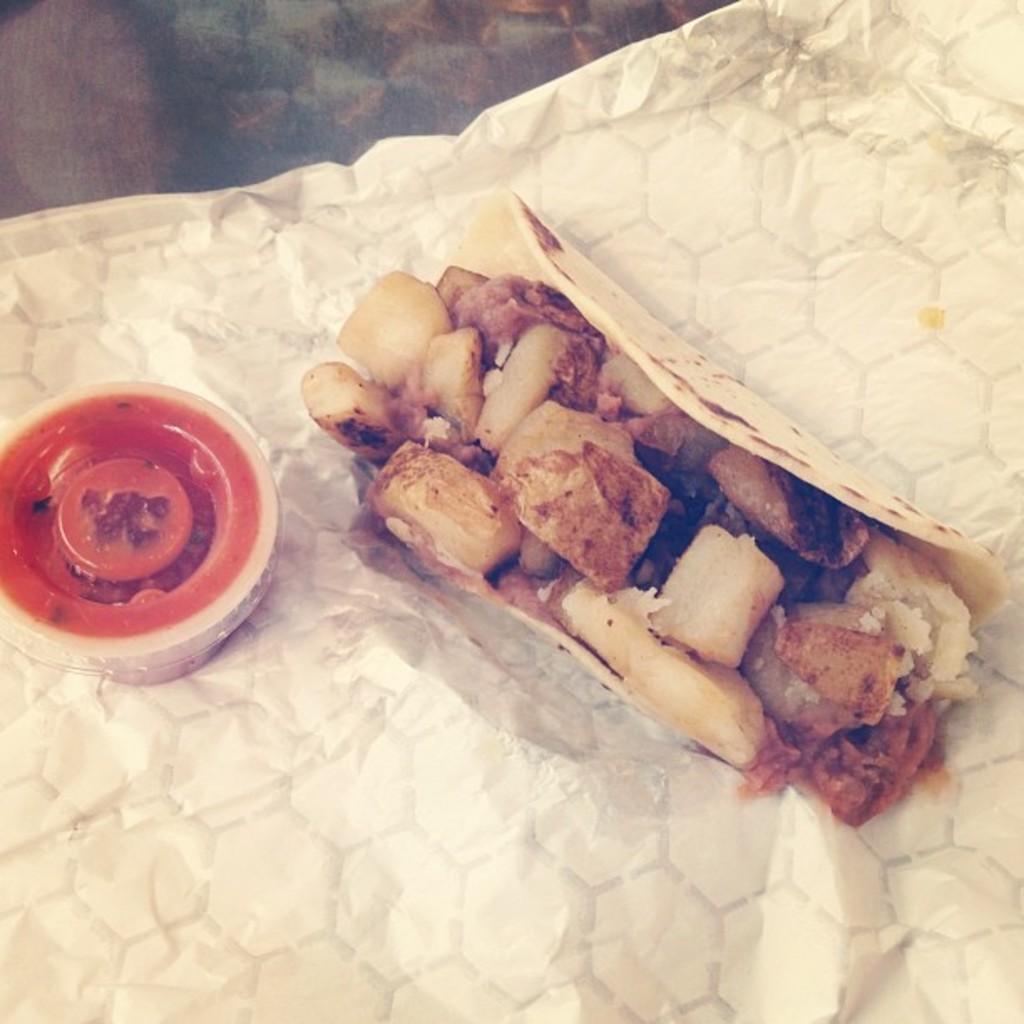Describe this image in one or two sentences. In the picture we can see a tissue in it we can see a food item and beside it we can see a small box with red color cap. 